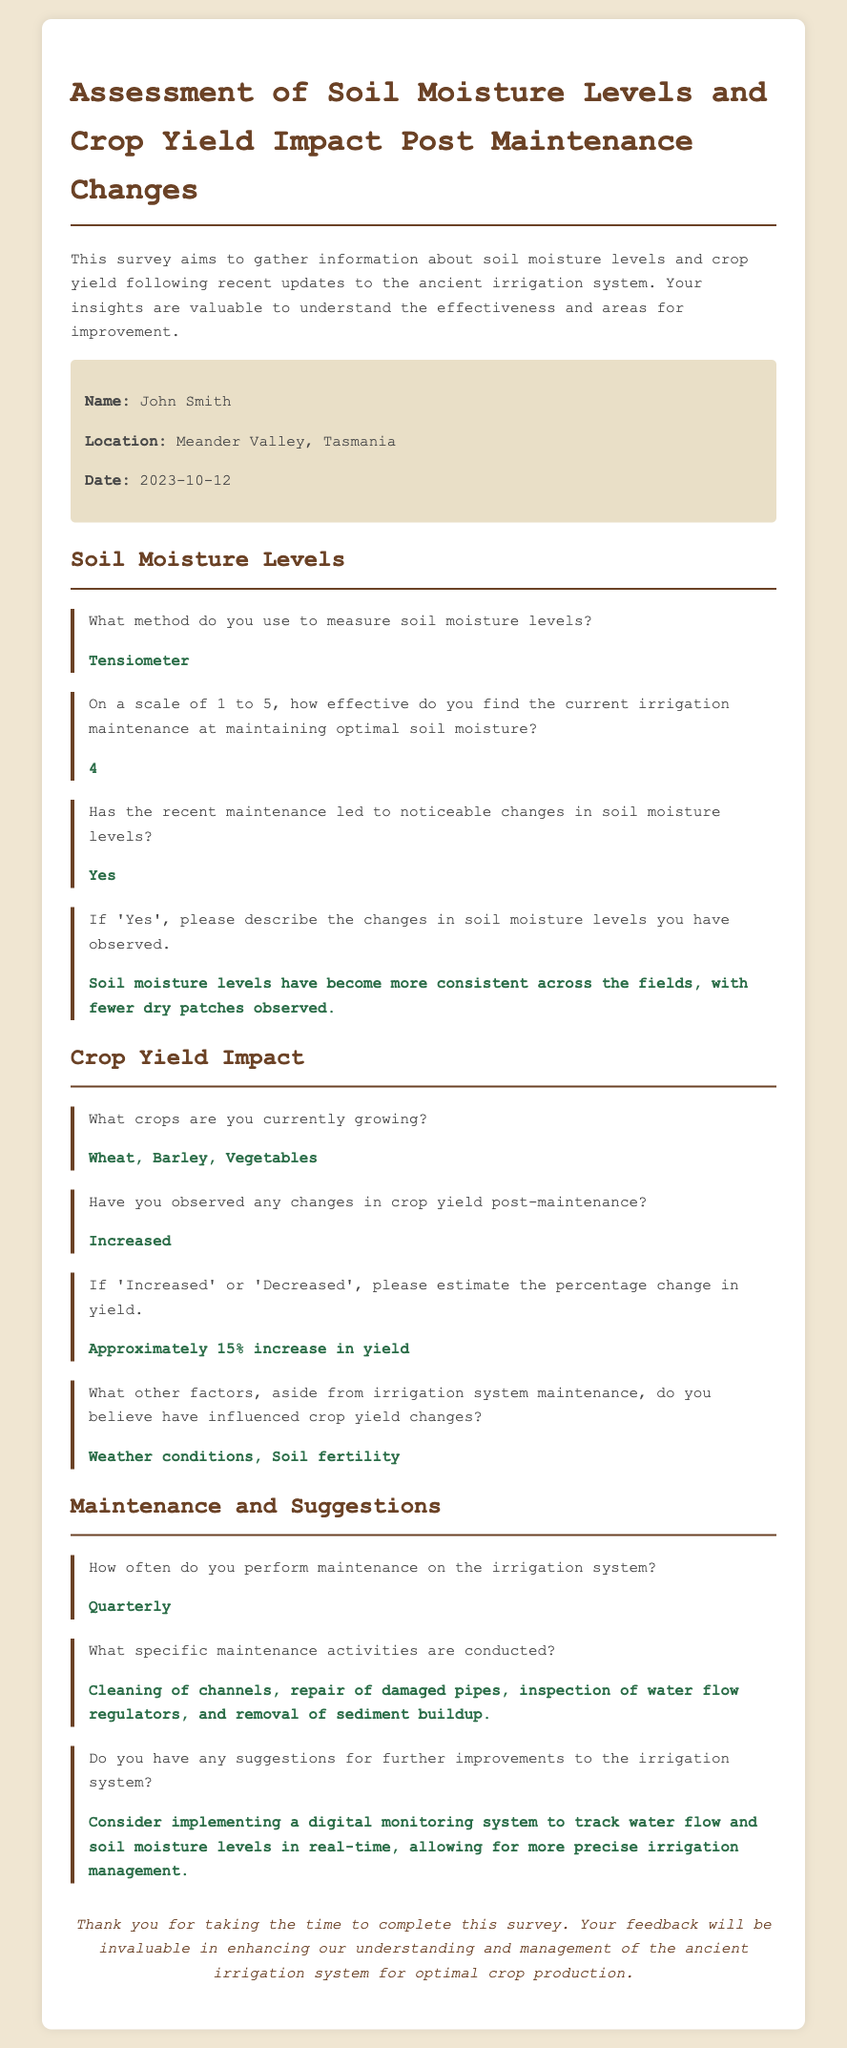What is the name of the landowner? The name of the landowner is provided in the personal details section of the survey.
Answer: John Smith What location is mentioned in the document? The location where the survey was filled out can be found in the personal details section.
Answer: Meander Valley, Tasmania On what date was the survey completed? The completion date is listed in the personal details section of the document.
Answer: 2023-10-12 What method is used to measure soil moisture levels? This information is provided in the soil moisture levels section of the survey.
Answer: Tensiometer How effective is the irrigation maintenance rated on a scale of 1 to 5? The effectiveness rating is mentioned directly in response to a specific question in the document.
Answer: 4 What crops are currently being grown? The crops being cultivated are detailed in the crop yield impact section of the survey.
Answer: Wheat, Barley, Vegetables What percentage increase in crop yield was estimated? This estimate can be found in the crop yield impact section of the survey.
Answer: Approximately 15% increase in yield How often is maintenance performed on the irrigation system? The frequency of maintenance is indicated in the maintenance and suggestions section.
Answer: Quarterly What suggestion is made for further improvements to the irrigation system? This suggestion is provided in the section discussing maintenance and suggestions.
Answer: Consider implementing a digital monitoring system 